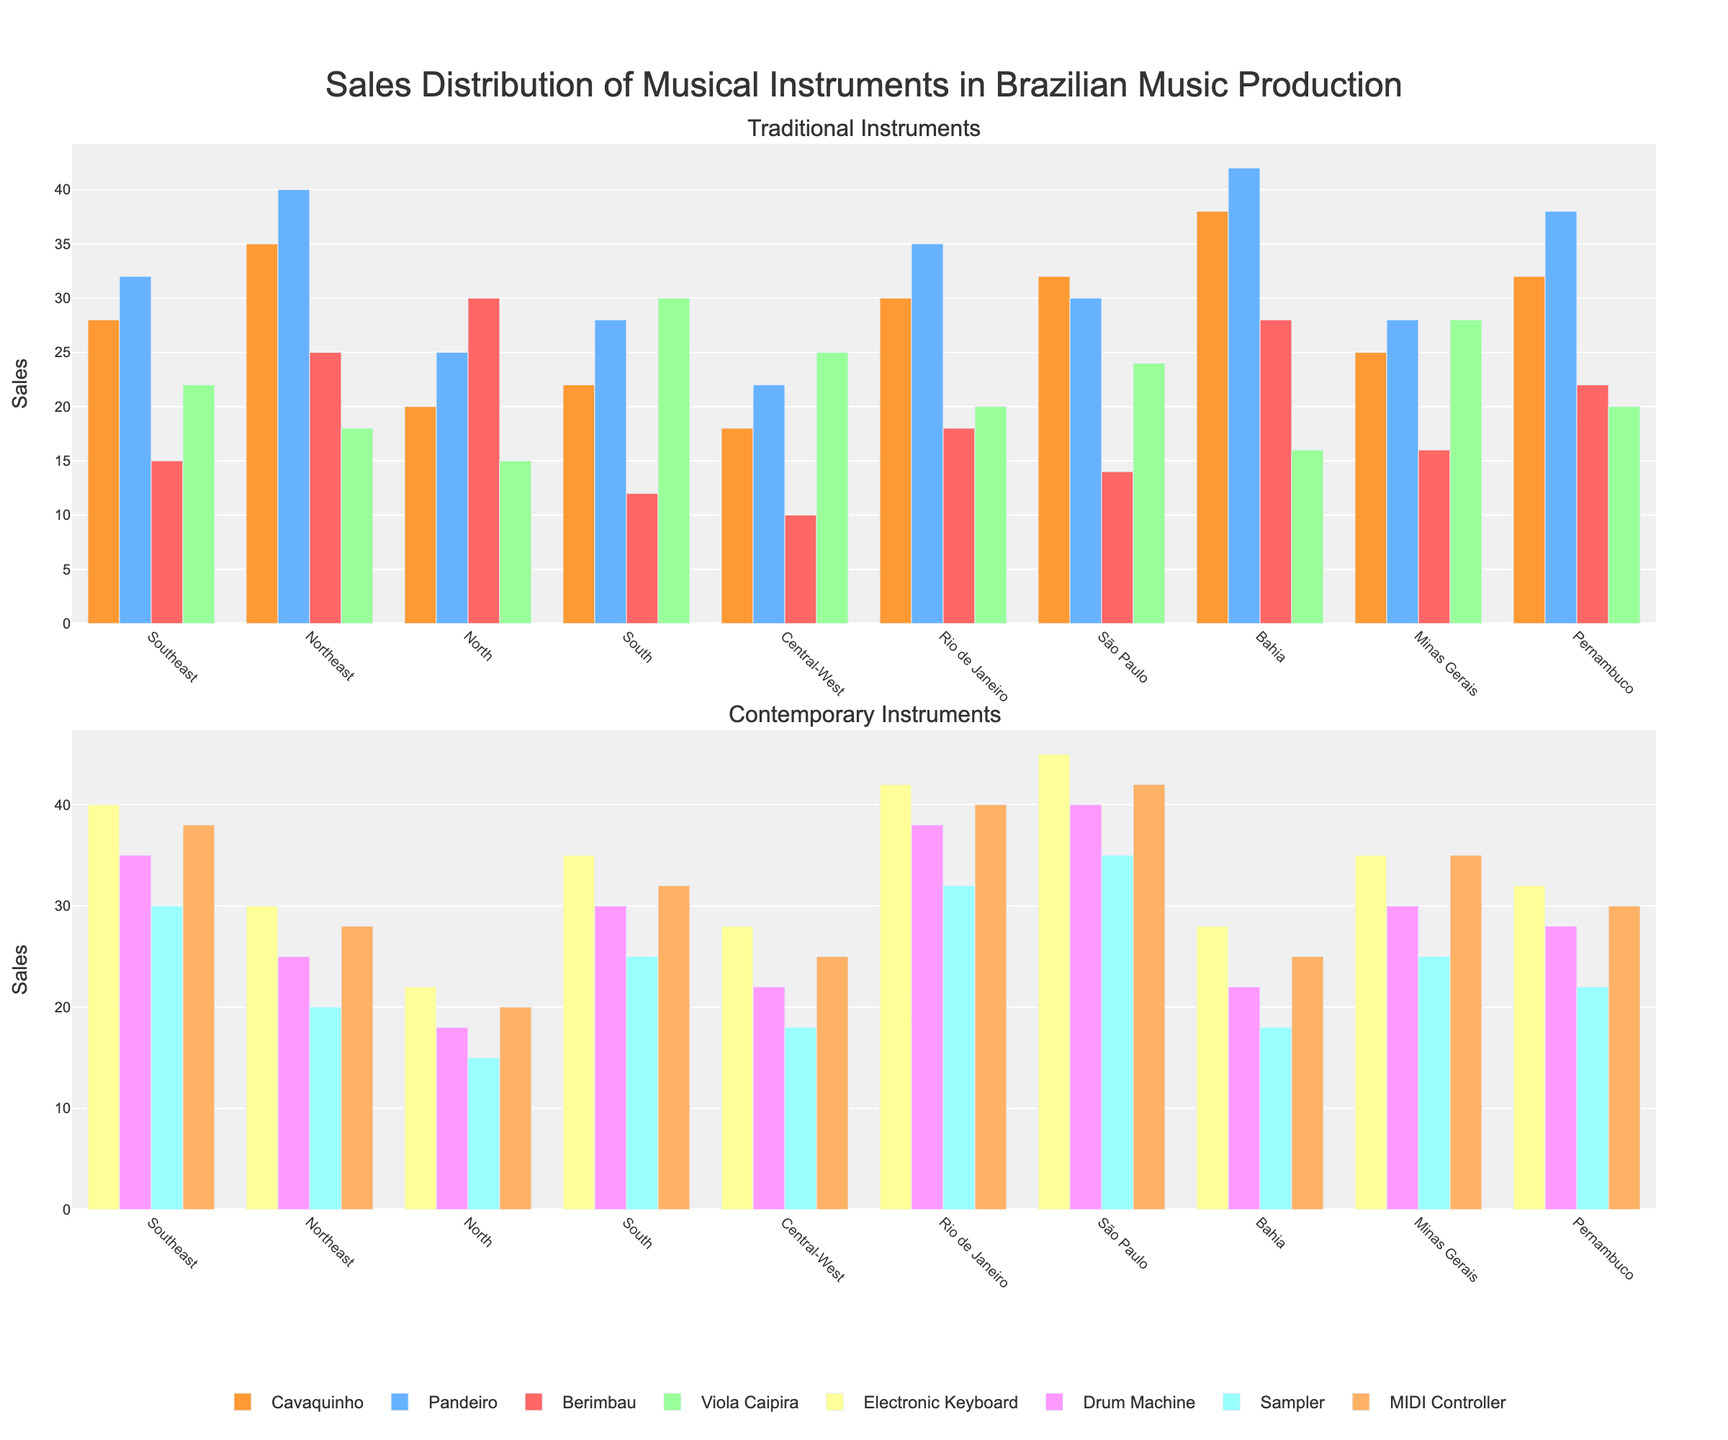What is the total sales of Electronic Keyboards in the Southeast and São Paulo regions? First, look at the bar showing sales for Electronic Keyboards in the Southeast region, which is 40. Then, look at the same for São Paulo, which is 45. Add them together: 40 + 45 = 85.
Answer: 85 Which region has the highest sales for Pandeiros? Compare the heights of the bars for Pandeiros across all regions. The Northeast region has the highest bar at 40.
Answer: Northeast Which instrument has the least sales in the Central-West region? Observe the heights of all bars for the Central-West region. The Berimbau has the smallest bar with a value of 10.
Answer: Berimbau How do sales of Drum Machines in Rio de Janeiro compare to those in Pernambuco? Look at the Drum Machines bar for Rio de Janeiro, which is 38, and for Pernambuco, which is 28. Rio de Janeiro's bar is higher.
Answer: Rio de Janeiro has higher sales What is the average sales of Traditional Instruments in the Bahia region? Traditional Instruments are Cavaquinho, Pandeiro, Berimbau, and Viola Caipira. First, find sales for each Traditional Instrument in Bahia: Cavaquinho (38), Pandeiro (42), Berimbau (28), and Viola Caipira (16). Sum them: 38 + 42 + 28 + 16 = 124. Then divide by the number of instruments, 124/4 = 31.
Answer: 31 How much more are MIDI Controller sales in São Paulo compared to the North region? Look at the MIDI Controller sales for São Paulo (42) and the North region (20). Subtract the smaller value from the larger: 42 - 20 = 22.
Answer: 22 Which region has the most balanced sales across all types of instruments? Compare the consistency of the bar heights for all instruments within each region. Look for a region where the bars are relatively equal in height throughout.
Answer: Minas Gerais Which region has the highest total sales for Contemporary Instruments? Contemporary Instruments are Electronic Keyboard, Drum Machine, Sampler, and MIDI Controller. Calculate the total sales for each region: 
- Southeast: 40 + 35 + 30 + 38 = 143
- Northeast: 30 + 25 + 20 + 28 = 103
- North: 22 + 18 + 15 + 20 = 75
- South: 35 + 30 + 25 + 32 = 122
- Central-West: 28 + 22 + 18 + 25 = 93
- Rio de Janeiro: 42 + 38 + 32 + 40 = 152
- São Paulo: 45 + 40 + 35 + 42 = 162
- Bahia: 28 + 22 + 18 + 25 = 93
- Minas Gerais: 35 + 30 + 25 + 35 = 125
- Pernambuco: 32 + 28 + 22 + 30 = 112
São Paulo has the highest total with 162.
Answer: São Paulo What is the difference in sales between the highest-selling and lowest-selling Traditional Instrument in the Southeast region? Identify sales of Traditional Instruments in the Southeast: Cavaquinho (28), Pandeiro (32), Berimbau (15), and Viola Caipira (22). The highest is Pandeiro at 32 and the lowest is Berimbau at 15. Subtract the smallest from the largest: 32 - 15 = 17.
Answer: 17 